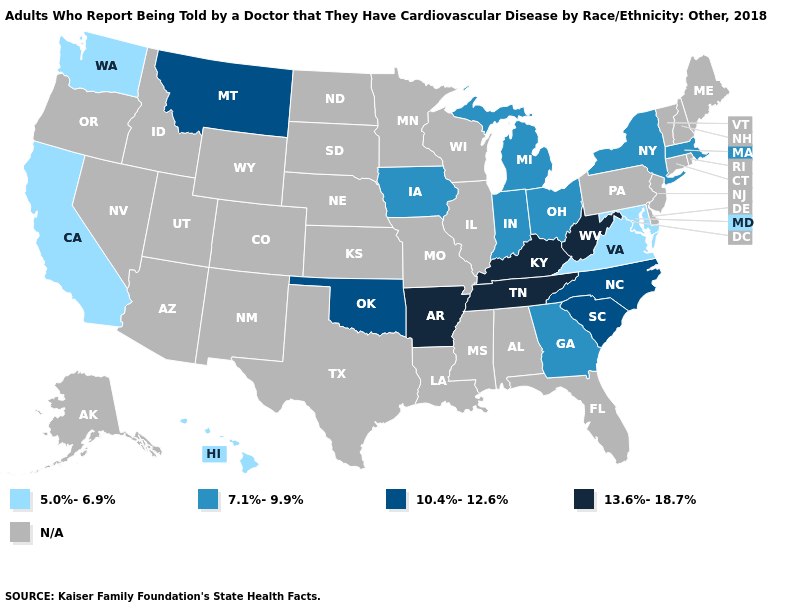Does the map have missing data?
Give a very brief answer. Yes. What is the value of Maine?
Answer briefly. N/A. What is the highest value in the Northeast ?
Give a very brief answer. 7.1%-9.9%. What is the value of Virginia?
Give a very brief answer. 5.0%-6.9%. Name the states that have a value in the range 5.0%-6.9%?
Be succinct. California, Hawaii, Maryland, Virginia, Washington. Name the states that have a value in the range N/A?
Quick response, please. Alabama, Alaska, Arizona, Colorado, Connecticut, Delaware, Florida, Idaho, Illinois, Kansas, Louisiana, Maine, Minnesota, Mississippi, Missouri, Nebraska, Nevada, New Hampshire, New Jersey, New Mexico, North Dakota, Oregon, Pennsylvania, Rhode Island, South Dakota, Texas, Utah, Vermont, Wisconsin, Wyoming. What is the highest value in the Northeast ?
Quick response, please. 7.1%-9.9%. What is the highest value in states that border Rhode Island?
Write a very short answer. 7.1%-9.9%. What is the value of Pennsylvania?
Give a very brief answer. N/A. Name the states that have a value in the range N/A?
Be succinct. Alabama, Alaska, Arizona, Colorado, Connecticut, Delaware, Florida, Idaho, Illinois, Kansas, Louisiana, Maine, Minnesota, Mississippi, Missouri, Nebraska, Nevada, New Hampshire, New Jersey, New Mexico, North Dakota, Oregon, Pennsylvania, Rhode Island, South Dakota, Texas, Utah, Vermont, Wisconsin, Wyoming. What is the highest value in states that border Arkansas?
Short answer required. 13.6%-18.7%. Name the states that have a value in the range 13.6%-18.7%?
Short answer required. Arkansas, Kentucky, Tennessee, West Virginia. What is the value of Alaska?
Be succinct. N/A. What is the highest value in the West ?
Be succinct. 10.4%-12.6%. What is the lowest value in the Northeast?
Keep it brief. 7.1%-9.9%. 